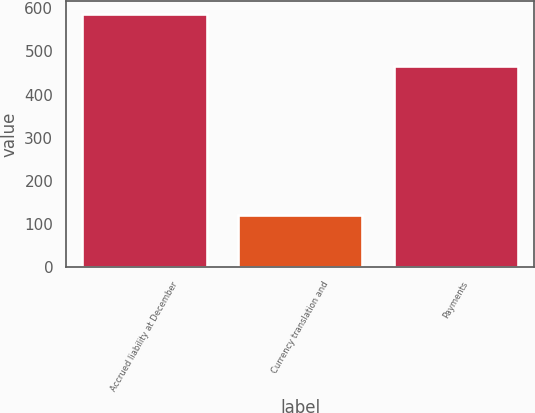Convert chart. <chart><loc_0><loc_0><loc_500><loc_500><bar_chart><fcel>Accrued liability at December<fcel>Currency translation and<fcel>Payments<nl><fcel>587<fcel>120<fcel>467<nl></chart> 